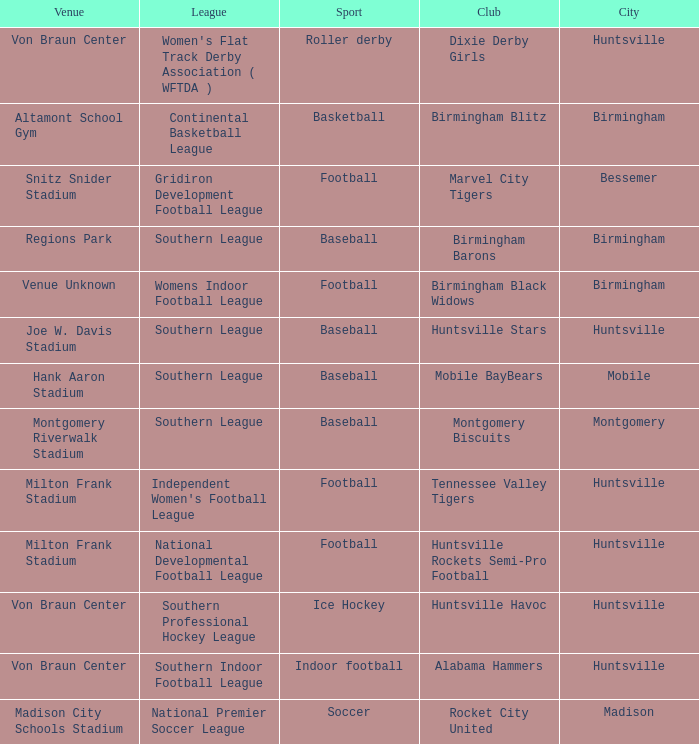Which sport was held in Huntsville at the Von Braun Center as part of the Southern Indoor Football League? Indoor football. Would you be able to parse every entry in this table? {'header': ['Venue', 'League', 'Sport', 'Club', 'City'], 'rows': [['Von Braun Center', "Women's Flat Track Derby Association ( WFTDA )", 'Roller derby', 'Dixie Derby Girls', 'Huntsville'], ['Altamont School Gym', 'Continental Basketball League', 'Basketball', 'Birmingham Blitz', 'Birmingham'], ['Snitz Snider Stadium', 'Gridiron Development Football League', 'Football', 'Marvel City Tigers', 'Bessemer'], ['Regions Park', 'Southern League', 'Baseball', 'Birmingham Barons', 'Birmingham'], ['Venue Unknown', 'Womens Indoor Football League', 'Football', 'Birmingham Black Widows', 'Birmingham'], ['Joe W. Davis Stadium', 'Southern League', 'Baseball', 'Huntsville Stars', 'Huntsville'], ['Hank Aaron Stadium', 'Southern League', 'Baseball', 'Mobile BayBears', 'Mobile'], ['Montgomery Riverwalk Stadium', 'Southern League', 'Baseball', 'Montgomery Biscuits', 'Montgomery'], ['Milton Frank Stadium', "Independent Women's Football League", 'Football', 'Tennessee Valley Tigers', 'Huntsville'], ['Milton Frank Stadium', 'National Developmental Football League', 'Football', 'Huntsville Rockets Semi-Pro Football', 'Huntsville'], ['Von Braun Center', 'Southern Professional Hockey League', 'Ice Hockey', 'Huntsville Havoc', 'Huntsville'], ['Von Braun Center', 'Southern Indoor Football League', 'Indoor football', 'Alabama Hammers', 'Huntsville'], ['Madison City Schools Stadium', 'National Premier Soccer League', 'Soccer', 'Rocket City United', 'Madison']]} 